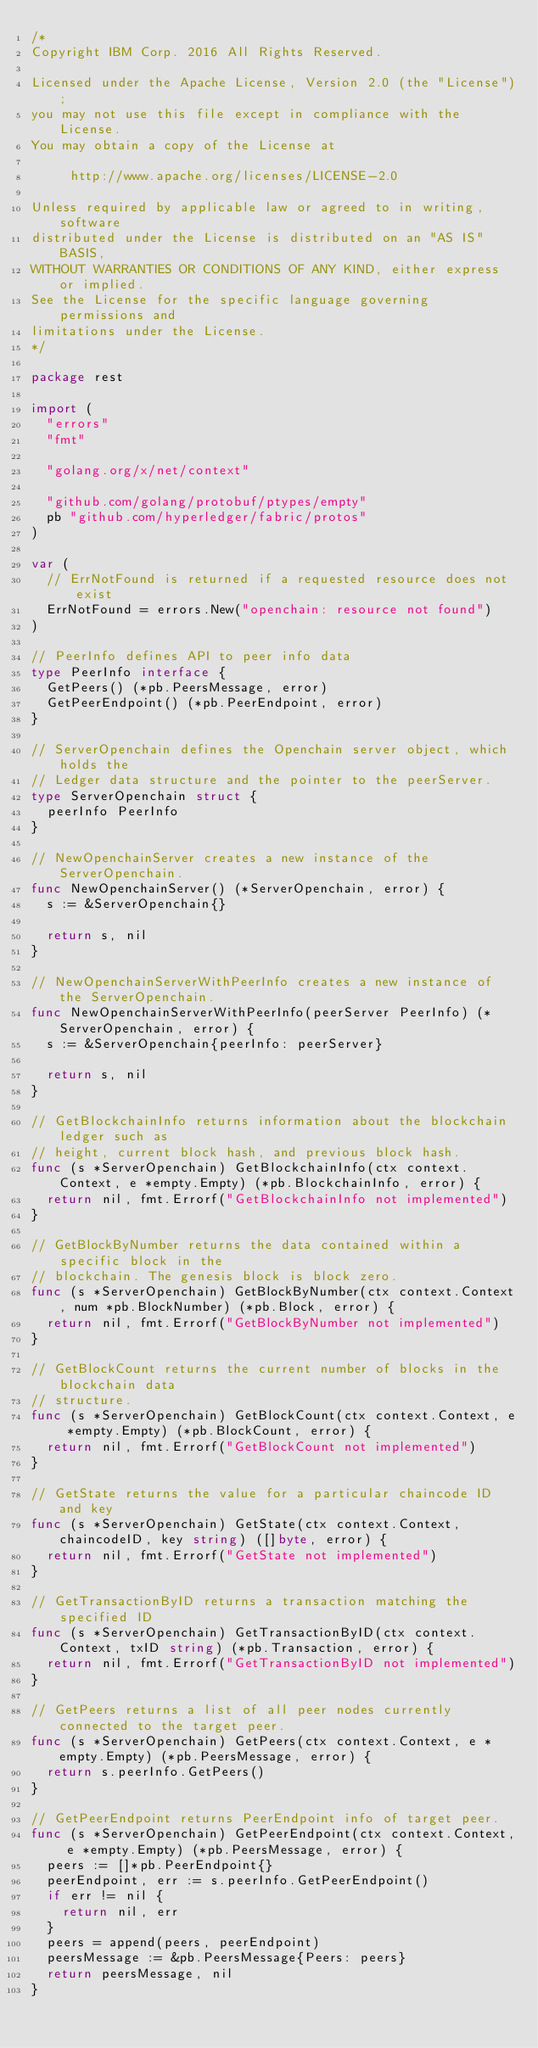<code> <loc_0><loc_0><loc_500><loc_500><_Go_>/*
Copyright IBM Corp. 2016 All Rights Reserved.

Licensed under the Apache License, Version 2.0 (the "License");
you may not use this file except in compliance with the License.
You may obtain a copy of the License at

		 http://www.apache.org/licenses/LICENSE-2.0

Unless required by applicable law or agreed to in writing, software
distributed under the License is distributed on an "AS IS" BASIS,
WITHOUT WARRANTIES OR CONDITIONS OF ANY KIND, either express or implied.
See the License for the specific language governing permissions and
limitations under the License.
*/

package rest

import (
	"errors"
	"fmt"

	"golang.org/x/net/context"

	"github.com/golang/protobuf/ptypes/empty"
	pb "github.com/hyperledger/fabric/protos"
)

var (
	// ErrNotFound is returned if a requested resource does not exist
	ErrNotFound = errors.New("openchain: resource not found")
)

// PeerInfo defines API to peer info data
type PeerInfo interface {
	GetPeers() (*pb.PeersMessage, error)
	GetPeerEndpoint() (*pb.PeerEndpoint, error)
}

// ServerOpenchain defines the Openchain server object, which holds the
// Ledger data structure and the pointer to the peerServer.
type ServerOpenchain struct {
	peerInfo PeerInfo
}

// NewOpenchainServer creates a new instance of the ServerOpenchain.
func NewOpenchainServer() (*ServerOpenchain, error) {
	s := &ServerOpenchain{}

	return s, nil
}

// NewOpenchainServerWithPeerInfo creates a new instance of the ServerOpenchain.
func NewOpenchainServerWithPeerInfo(peerServer PeerInfo) (*ServerOpenchain, error) {
	s := &ServerOpenchain{peerInfo: peerServer}

	return s, nil
}

// GetBlockchainInfo returns information about the blockchain ledger such as
// height, current block hash, and previous block hash.
func (s *ServerOpenchain) GetBlockchainInfo(ctx context.Context, e *empty.Empty) (*pb.BlockchainInfo, error) {
	return nil, fmt.Errorf("GetBlockchainInfo not implemented")
}

// GetBlockByNumber returns the data contained within a specific block in the
// blockchain. The genesis block is block zero.
func (s *ServerOpenchain) GetBlockByNumber(ctx context.Context, num *pb.BlockNumber) (*pb.Block, error) {
	return nil, fmt.Errorf("GetBlockByNumber not implemented")
}

// GetBlockCount returns the current number of blocks in the blockchain data
// structure.
func (s *ServerOpenchain) GetBlockCount(ctx context.Context, e *empty.Empty) (*pb.BlockCount, error) {
	return nil, fmt.Errorf("GetBlockCount not implemented")
}

// GetState returns the value for a particular chaincode ID and key
func (s *ServerOpenchain) GetState(ctx context.Context, chaincodeID, key string) ([]byte, error) {
	return nil, fmt.Errorf("GetState not implemented")
}

// GetTransactionByID returns a transaction matching the specified ID
func (s *ServerOpenchain) GetTransactionByID(ctx context.Context, txID string) (*pb.Transaction, error) {
	return nil, fmt.Errorf("GetTransactionByID not implemented")
}

// GetPeers returns a list of all peer nodes currently connected to the target peer.
func (s *ServerOpenchain) GetPeers(ctx context.Context, e *empty.Empty) (*pb.PeersMessage, error) {
	return s.peerInfo.GetPeers()
}

// GetPeerEndpoint returns PeerEndpoint info of target peer.
func (s *ServerOpenchain) GetPeerEndpoint(ctx context.Context, e *empty.Empty) (*pb.PeersMessage, error) {
	peers := []*pb.PeerEndpoint{}
	peerEndpoint, err := s.peerInfo.GetPeerEndpoint()
	if err != nil {
		return nil, err
	}
	peers = append(peers, peerEndpoint)
	peersMessage := &pb.PeersMessage{Peers: peers}
	return peersMessage, nil
}
</code> 